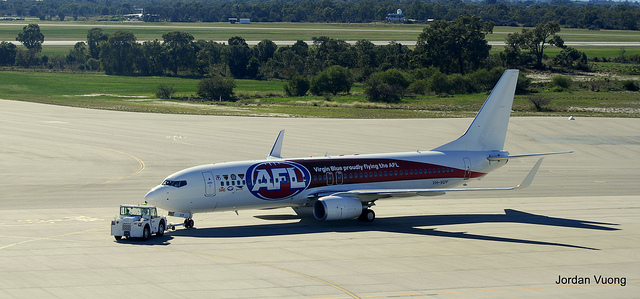Please extract the text content from this image. AFL Vuong Jordan 